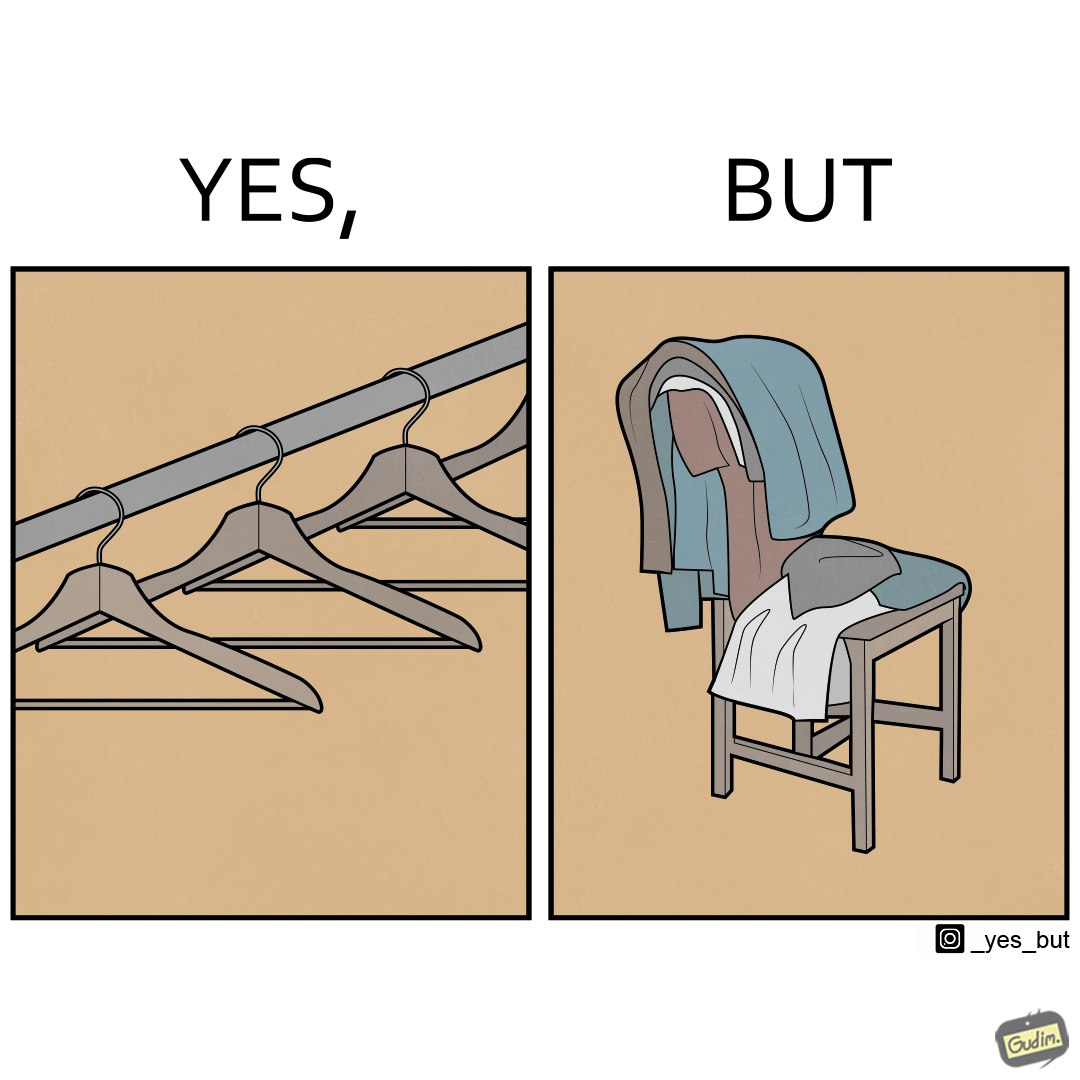Is there satirical content in this image? Yes, this image is satirical. 